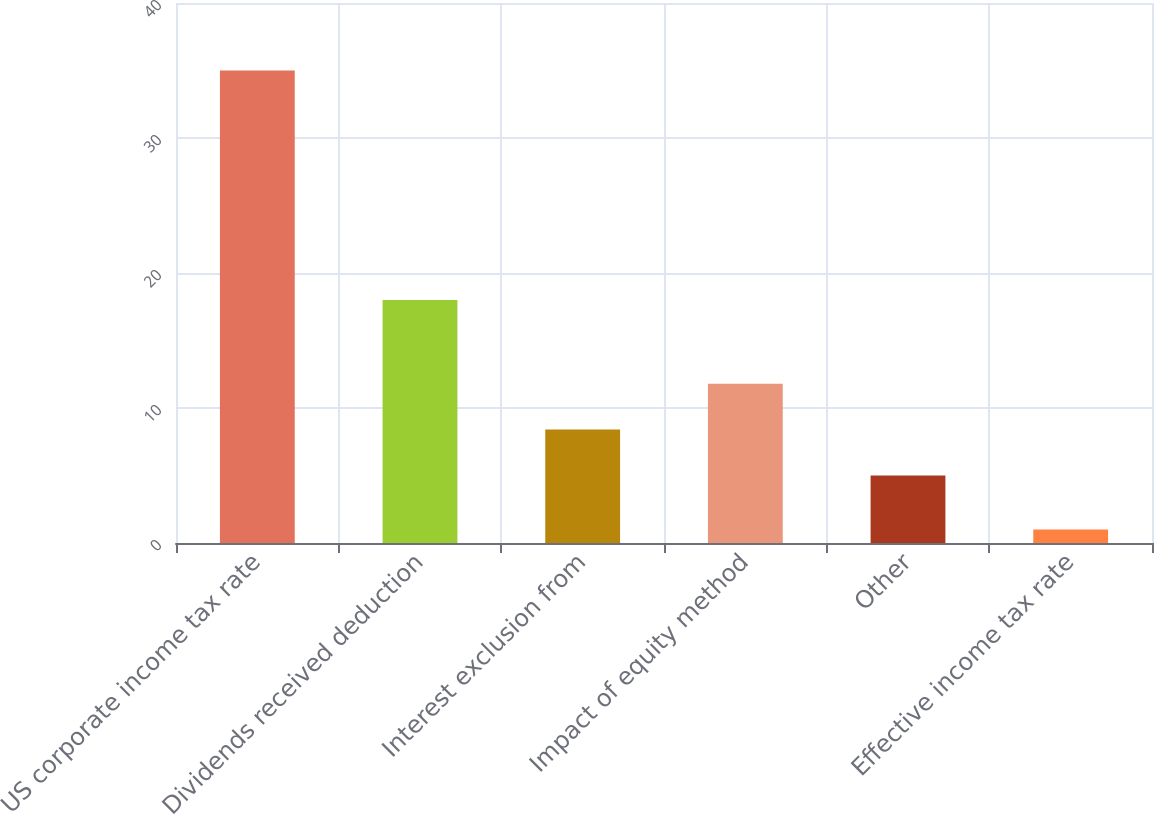Convert chart. <chart><loc_0><loc_0><loc_500><loc_500><bar_chart><fcel>US corporate income tax rate<fcel>Dividends received deduction<fcel>Interest exclusion from<fcel>Impact of equity method<fcel>Other<fcel>Effective income tax rate<nl><fcel>35<fcel>18<fcel>8.4<fcel>11.8<fcel>5<fcel>1<nl></chart> 